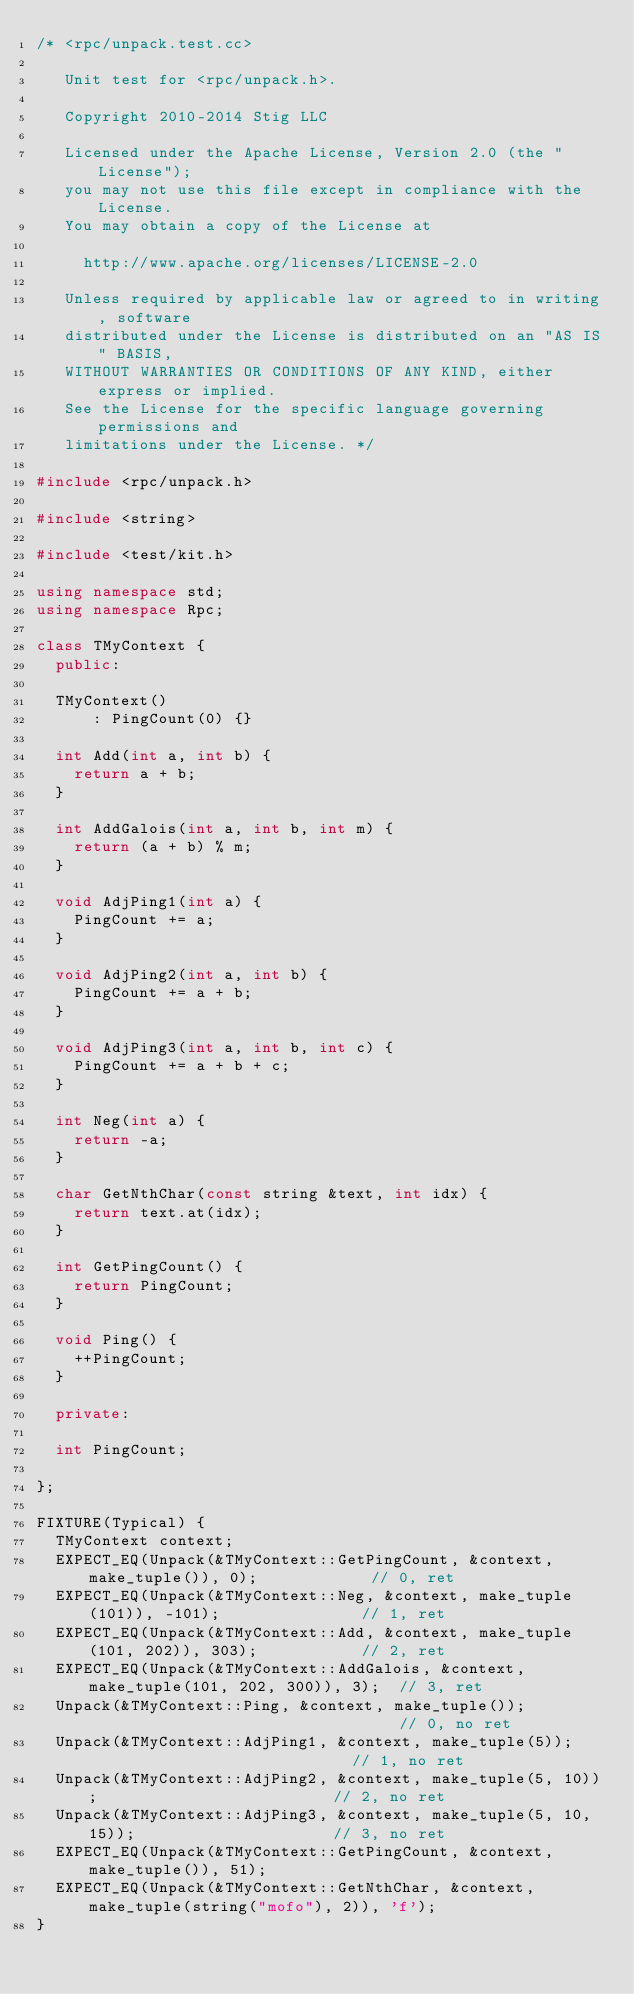Convert code to text. <code><loc_0><loc_0><loc_500><loc_500><_C++_>/* <rpc/unpack.test.cc>

   Unit test for <rpc/unpack.h>.

   Copyright 2010-2014 Stig LLC

   Licensed under the Apache License, Version 2.0 (the "License");
   you may not use this file except in compliance with the License.
   You may obtain a copy of the License at

     http://www.apache.org/licenses/LICENSE-2.0

   Unless required by applicable law or agreed to in writing, software
   distributed under the License is distributed on an "AS IS" BASIS,
   WITHOUT WARRANTIES OR CONDITIONS OF ANY KIND, either express or implied.
   See the License for the specific language governing permissions and
   limitations under the License. */

#include <rpc/unpack.h>

#include <string>

#include <test/kit.h>

using namespace std;
using namespace Rpc;

class TMyContext {
  public:

  TMyContext()
      : PingCount(0) {}

  int Add(int a, int b) {
    return a + b;
  }

  int AddGalois(int a, int b, int m) {
    return (a + b) % m;
  }

  void AdjPing1(int a) {
    PingCount += a;
  }

  void AdjPing2(int a, int b) {
    PingCount += a + b;
  }

  void AdjPing3(int a, int b, int c) {
    PingCount += a + b + c;
  }

  int Neg(int a) {
    return -a;
  }

  char GetNthChar(const string &text, int idx) {
    return text.at(idx);
  }

  int GetPingCount() {
    return PingCount;
  }

  void Ping() {
    ++PingCount;
  }

  private:

  int PingCount;

};

FIXTURE(Typical) {
  TMyContext context;
  EXPECT_EQ(Unpack(&TMyContext::GetPingCount, &context, make_tuple()), 0);            // 0, ret
  EXPECT_EQ(Unpack(&TMyContext::Neg, &context, make_tuple(101)), -101);               // 1, ret
  EXPECT_EQ(Unpack(&TMyContext::Add, &context, make_tuple(101, 202)), 303);           // 2, ret
  EXPECT_EQ(Unpack(&TMyContext::AddGalois, &context, make_tuple(101, 202, 300)), 3);  // 3, ret
  Unpack(&TMyContext::Ping, &context, make_tuple());                                  // 0, no ret
  Unpack(&TMyContext::AdjPing1, &context, make_tuple(5));                             // 1, no ret
  Unpack(&TMyContext::AdjPing2, &context, make_tuple(5, 10));                         // 2, no ret
  Unpack(&TMyContext::AdjPing3, &context, make_tuple(5, 10, 15));                     // 3, no ret
  EXPECT_EQ(Unpack(&TMyContext::GetPingCount, &context, make_tuple()), 51);
  EXPECT_EQ(Unpack(&TMyContext::GetNthChar, &context, make_tuple(string("mofo"), 2)), 'f');
}
</code> 